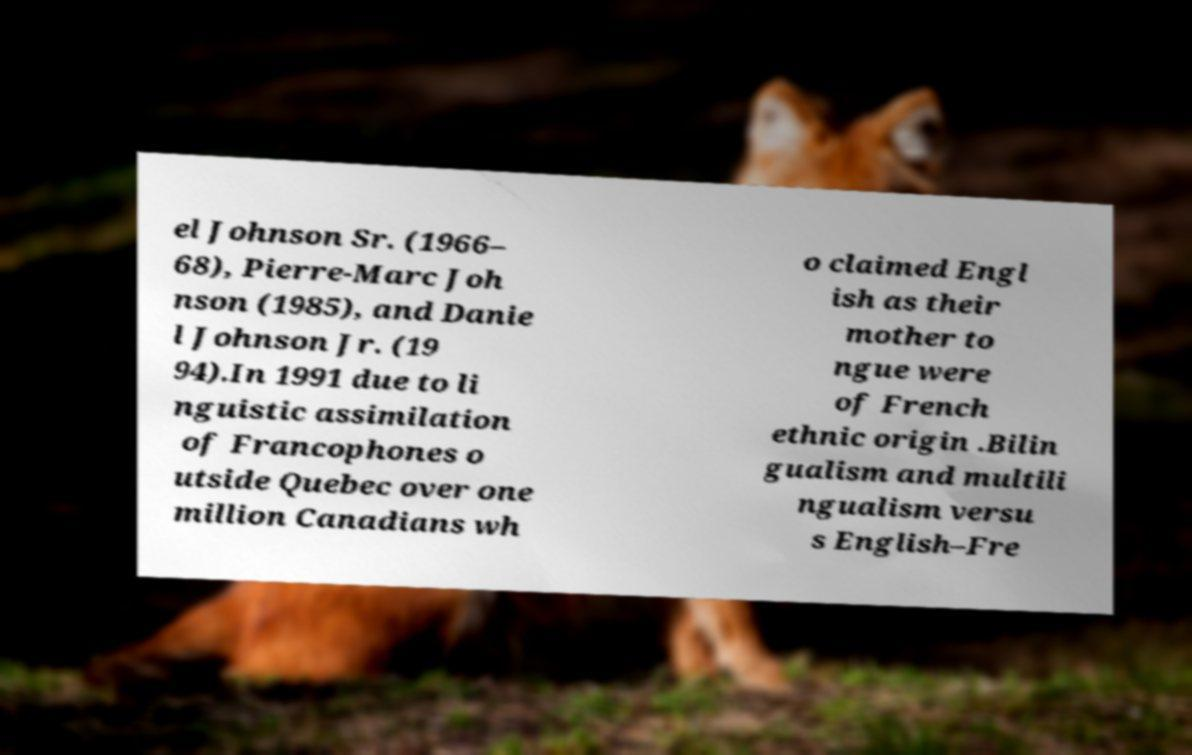There's text embedded in this image that I need extracted. Can you transcribe it verbatim? el Johnson Sr. (1966– 68), Pierre-Marc Joh nson (1985), and Danie l Johnson Jr. (19 94).In 1991 due to li nguistic assimilation of Francophones o utside Quebec over one million Canadians wh o claimed Engl ish as their mother to ngue were of French ethnic origin .Bilin gualism and multili ngualism versu s English–Fre 